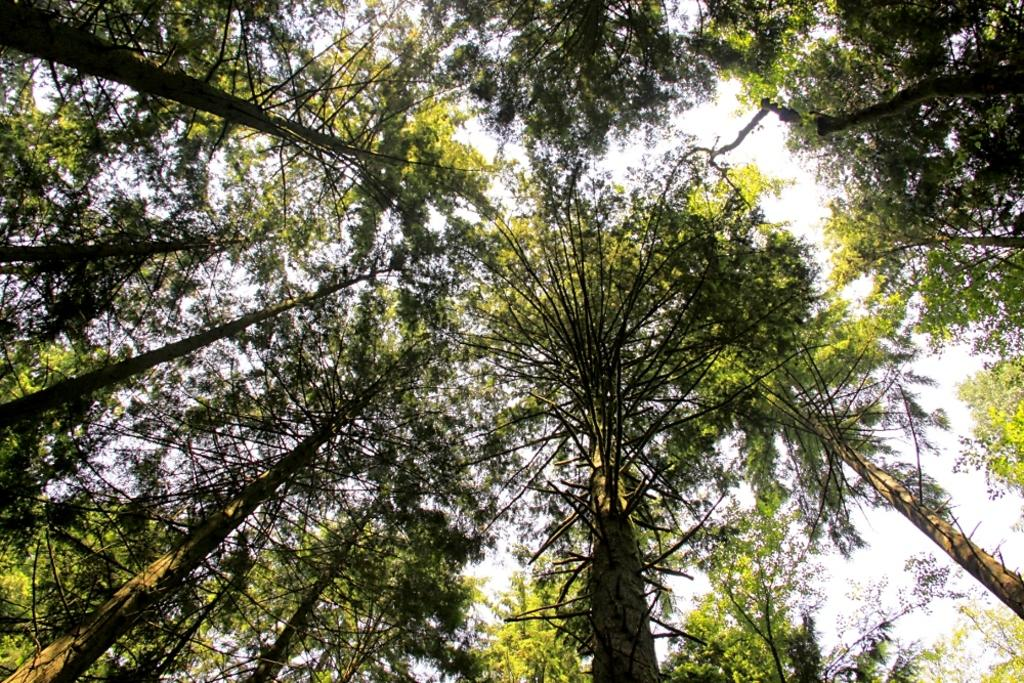What type of vegetation can be seen in the image? There are trees in the image. What type of cheese can be seen hanging from the trees in the image? There is no cheese present in the image; it only features trees. How many fish are visible swimming in the trees in the image? There are no fish present in the image, as it only features trees. 